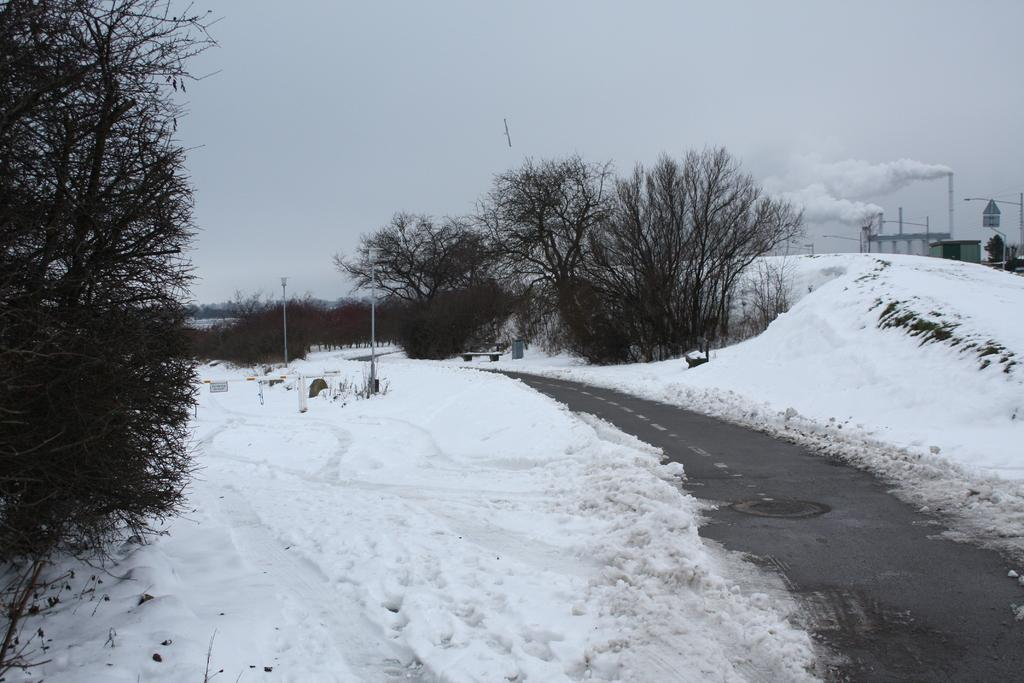What is coming out of the chimneys in the image? Smoke is coming out of the chimneys in the image. What type of structures can be seen along the streets in the image? Street poles and street lights are visible in the image. What type of surface can be seen in the image? Roads are present in the image. What is the weather like in the image? Snow is visible in the image, indicating a snowy environment. What type of vegetation is present in the image? Trees are present in the image. What is visible above the structures and vegetation in the image? The sky is visible in the image. How many sheep are visible in the image? There are no sheep present in the image. What type of watch is the person wearing in the image? There are no people or watches visible in the image. Can you describe the kicking motion of the person in the image? There are no people or kicking motions present in the image. 